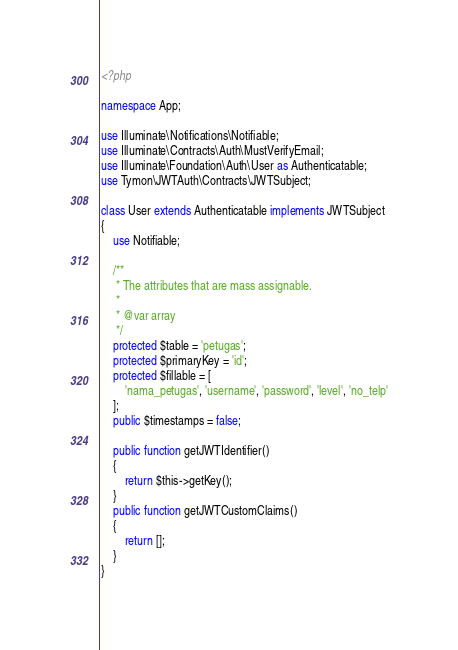<code> <loc_0><loc_0><loc_500><loc_500><_PHP_><?php

namespace App;

use Illuminate\Notifications\Notifiable;
use Illuminate\Contracts\Auth\MustVerifyEmail;
use Illuminate\Foundation\Auth\User as Authenticatable;
use Tymon\JWTAuth\Contracts\JWTSubject;

class User extends Authenticatable implements JWTSubject
{
    use Notifiable;

    /**
     * The attributes that are mass assignable.
     *
     * @var array
     */
    protected $table = 'petugas';
    protected $primaryKey = 'id';
    protected $fillable = [
        'nama_petugas', 'username', 'password', 'level', 'no_telp'
    ];
    public $timestamps = false;

    public function getJWTIdentifier()
    {
        return $this->getKey();
    }
    public function getJWTCustomClaims()
    {
        return [];
    }
}
</code> 